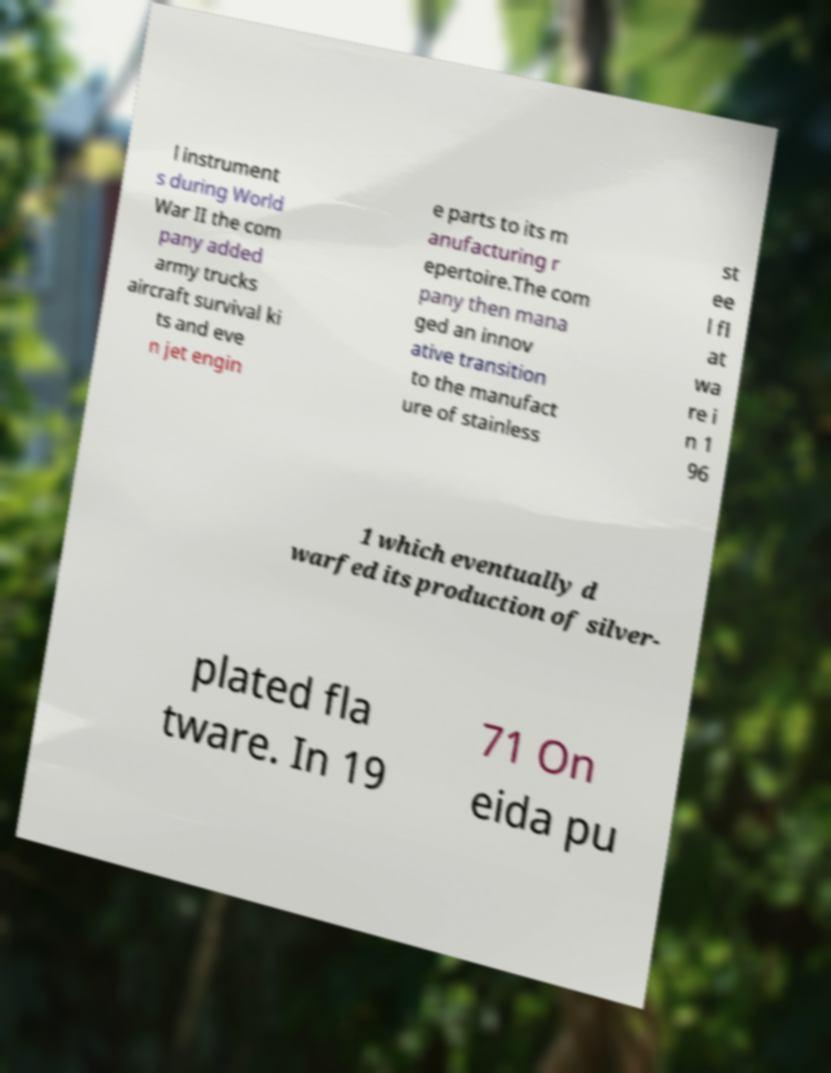Please read and relay the text visible in this image. What does it say? l instrument s during World War II the com pany added army trucks aircraft survival ki ts and eve n jet engin e parts to its m anufacturing r epertoire.The com pany then mana ged an innov ative transition to the manufact ure of stainless st ee l fl at wa re i n 1 96 1 which eventually d warfed its production of silver- plated fla tware. In 19 71 On eida pu 